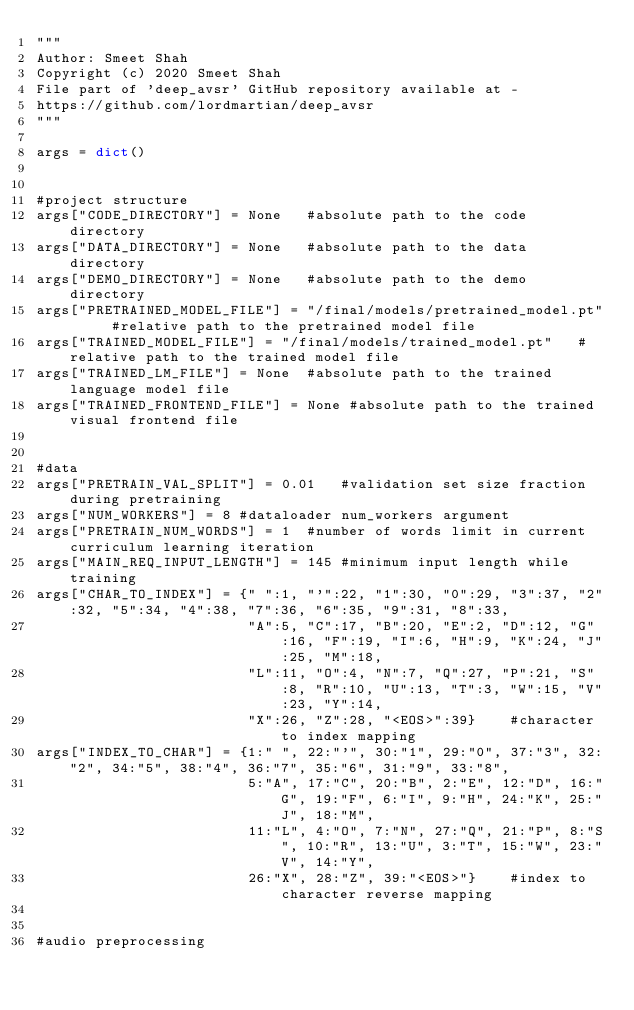Convert code to text. <code><loc_0><loc_0><loc_500><loc_500><_Python_>"""
Author: Smeet Shah
Copyright (c) 2020 Smeet Shah
File part of 'deep_avsr' GitHub repository available at -
https://github.com/lordmartian/deep_avsr
"""

args = dict()


#project structure
args["CODE_DIRECTORY"] = None   #absolute path to the code directory
args["DATA_DIRECTORY"] = None   #absolute path to the data directory
args["DEMO_DIRECTORY"] = None   #absolute path to the demo directory
args["PRETRAINED_MODEL_FILE"] = "/final/models/pretrained_model.pt"     #relative path to the pretrained model file
args["TRAINED_MODEL_FILE"] = "/final/models/trained_model.pt"   #relative path to the trained model file
args["TRAINED_LM_FILE"] = None  #absolute path to the trained language model file
args["TRAINED_FRONTEND_FILE"] = None #absolute path to the trained visual frontend file


#data
args["PRETRAIN_VAL_SPLIT"] = 0.01   #validation set size fraction during pretraining
args["NUM_WORKERS"] = 8 #dataloader num_workers argument
args["PRETRAIN_NUM_WORDS"] = 1  #number of words limit in current curriculum learning iteration
args["MAIN_REQ_INPUT_LENGTH"] = 145 #minimum input length while training
args["CHAR_TO_INDEX"] = {" ":1, "'":22, "1":30, "0":29, "3":37, "2":32, "5":34, "4":38, "7":36, "6":35, "9":31, "8":33,
                         "A":5, "C":17, "B":20, "E":2, "D":12, "G":16, "F":19, "I":6, "H":9, "K":24, "J":25, "M":18,
                         "L":11, "O":4, "N":7, "Q":27, "P":21, "S":8, "R":10, "U":13, "T":3, "W":15, "V":23, "Y":14,
                         "X":26, "Z":28, "<EOS>":39}    #character to index mapping
args["INDEX_TO_CHAR"] = {1:" ", 22:"'", 30:"1", 29:"0", 37:"3", 32:"2", 34:"5", 38:"4", 36:"7", 35:"6", 31:"9", 33:"8",
                         5:"A", 17:"C", 20:"B", 2:"E", 12:"D", 16:"G", 19:"F", 6:"I", 9:"H", 24:"K", 25:"J", 18:"M",
                         11:"L", 4:"O", 7:"N", 27:"Q", 21:"P", 8:"S", 10:"R", 13:"U", 3:"T", 15:"W", 23:"V", 14:"Y",
                         26:"X", 28:"Z", 39:"<EOS>"}    #index to character reverse mapping


#audio preprocessing</code> 